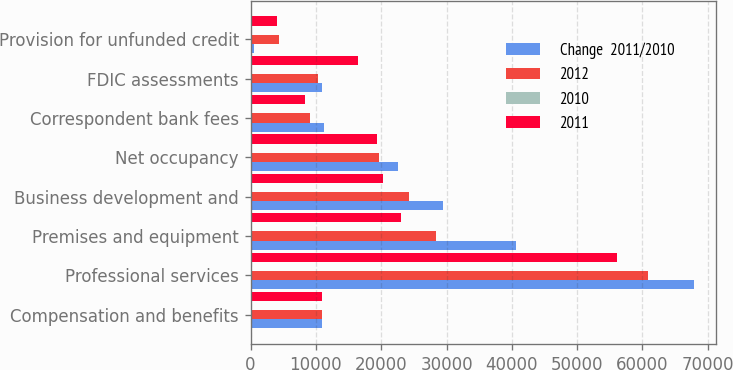Convert chart. <chart><loc_0><loc_0><loc_500><loc_500><stacked_bar_chart><ecel><fcel>Compensation and benefits<fcel>Professional services<fcel>Premises and equipment<fcel>Business development and<fcel>Net occupancy<fcel>Correspondent bank fees<fcel>FDIC assessments<fcel>Provision for unfunded credit<nl><fcel>Change  2011/2010<fcel>10959<fcel>67845<fcel>40689<fcel>29409<fcel>22536<fcel>11168<fcel>10959<fcel>488<nl><fcel>2012<fcel>10959<fcel>60807<fcel>28335<fcel>24250<fcel>19624<fcel>9052<fcel>10298<fcel>4397<nl><fcel>2010<fcel>4.4<fcel>11.6<fcel>43.6<fcel>21.3<fcel>14.8<fcel>23.4<fcel>6.4<fcel>88.9<nl><fcel>2011<fcel>10959<fcel>56123<fcel>23023<fcel>20237<fcel>19378<fcel>8379<fcel>16498<fcel>4083<nl></chart> 